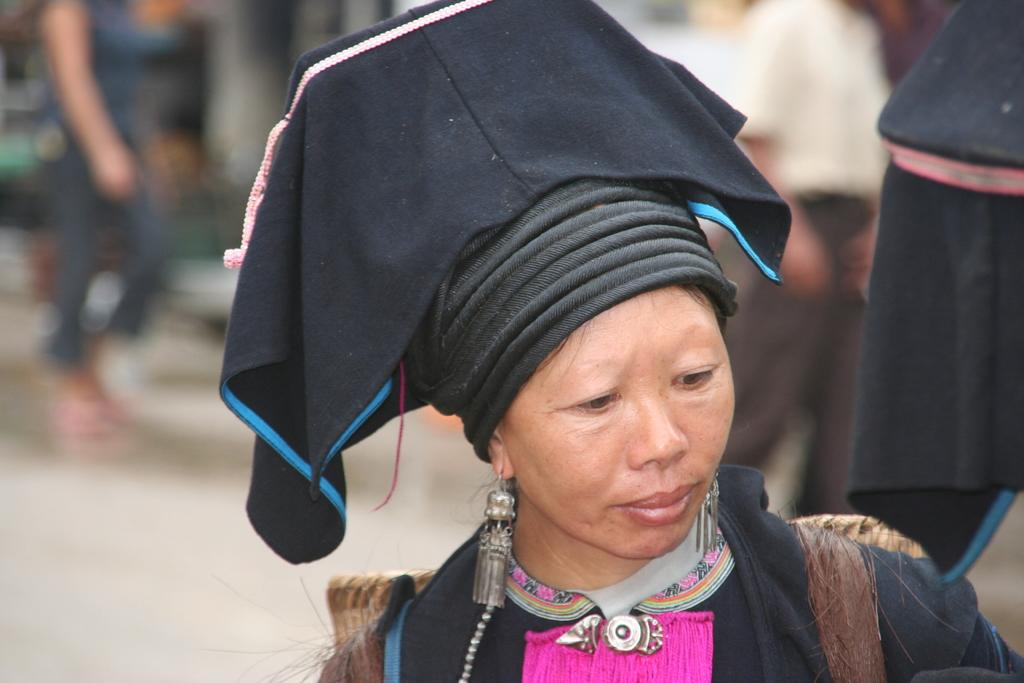What is the main subject of the image? There is a person in the image. Can you describe the person's attire? The person is wearing a black and pink colored dress and a black colored hat. How would you describe the background of the image? The background is blurry. Are there any other people visible in the image? Yes, there are few persons standing on the ground in the background. What type of salt is being advertised in the image? There is no salt or advertisement present in the image. What is the person doing with the board in the image? There is no board present in the image. 